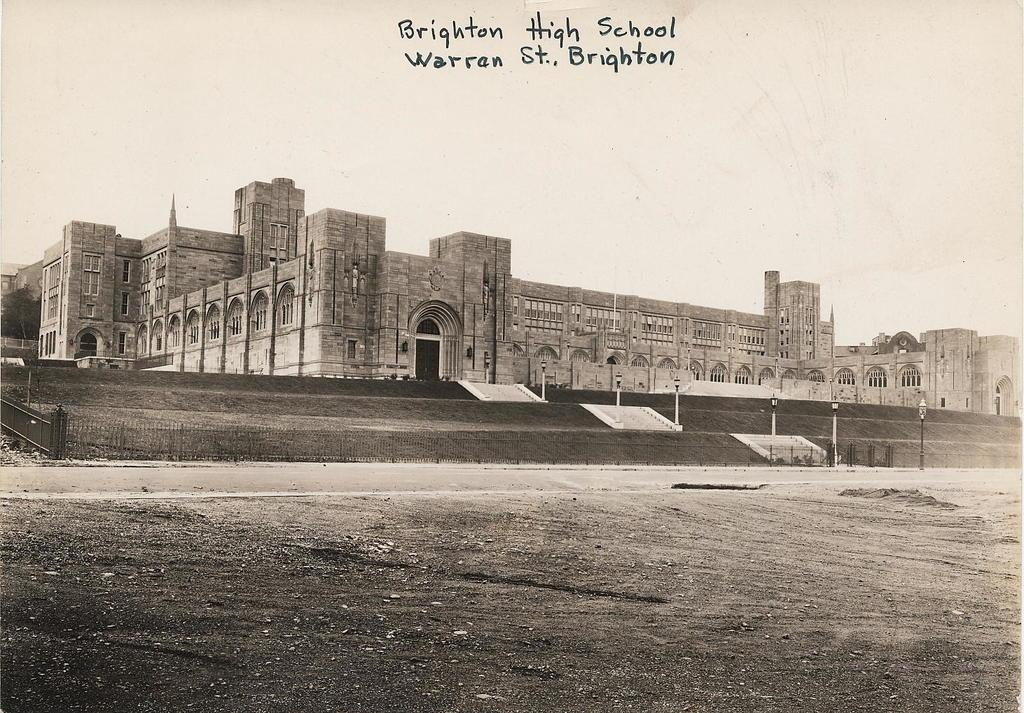<image>
Create a compact narrative representing the image presented. an old photograph titled Brighton High School Warron St. 